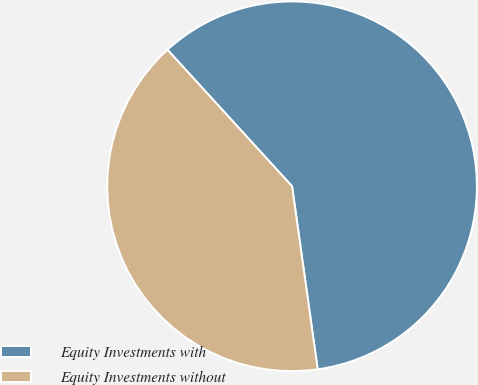Convert chart to OTSL. <chart><loc_0><loc_0><loc_500><loc_500><pie_chart><fcel>Equity Investments with<fcel>Equity Investments without<nl><fcel>59.56%<fcel>40.44%<nl></chart> 